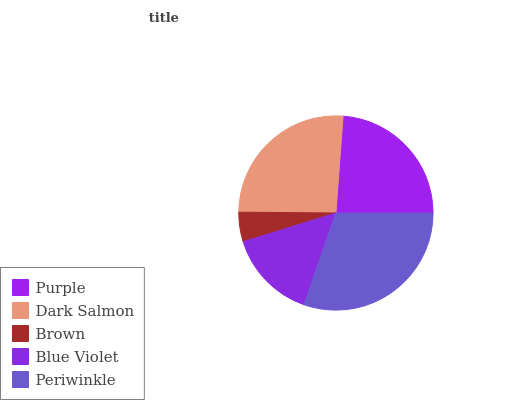Is Brown the minimum?
Answer yes or no. Yes. Is Periwinkle the maximum?
Answer yes or no. Yes. Is Dark Salmon the minimum?
Answer yes or no. No. Is Dark Salmon the maximum?
Answer yes or no. No. Is Dark Salmon greater than Purple?
Answer yes or no. Yes. Is Purple less than Dark Salmon?
Answer yes or no. Yes. Is Purple greater than Dark Salmon?
Answer yes or no. No. Is Dark Salmon less than Purple?
Answer yes or no. No. Is Purple the high median?
Answer yes or no. Yes. Is Purple the low median?
Answer yes or no. Yes. Is Brown the high median?
Answer yes or no. No. Is Periwinkle the low median?
Answer yes or no. No. 